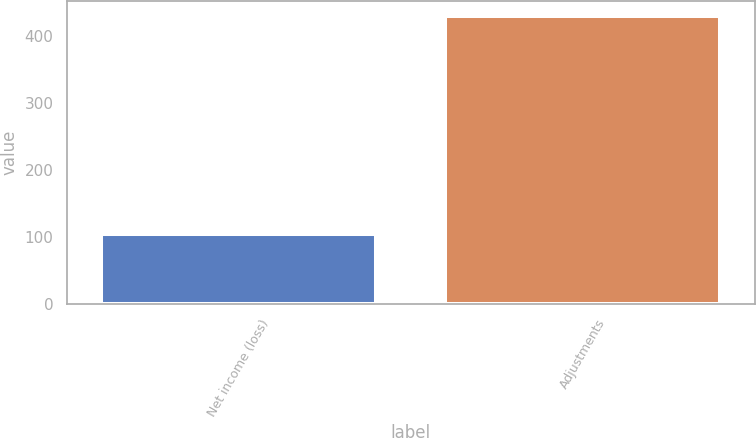Convert chart. <chart><loc_0><loc_0><loc_500><loc_500><bar_chart><fcel>Net income (loss)<fcel>Adjustments<nl><fcel>104<fcel>430<nl></chart> 